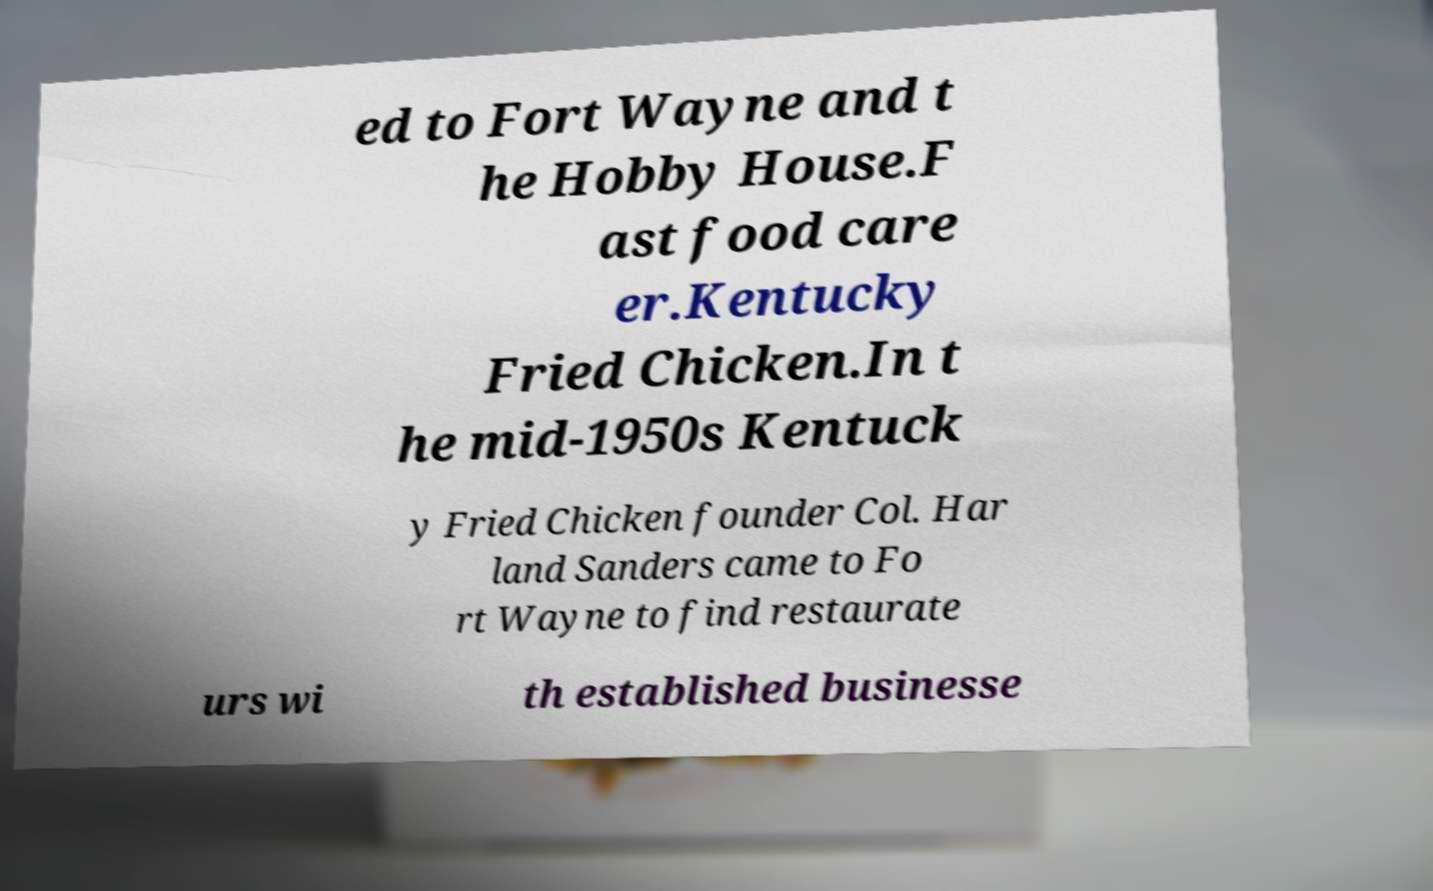I need the written content from this picture converted into text. Can you do that? ed to Fort Wayne and t he Hobby House.F ast food care er.Kentucky Fried Chicken.In t he mid-1950s Kentuck y Fried Chicken founder Col. Har land Sanders came to Fo rt Wayne to find restaurate urs wi th established businesse 